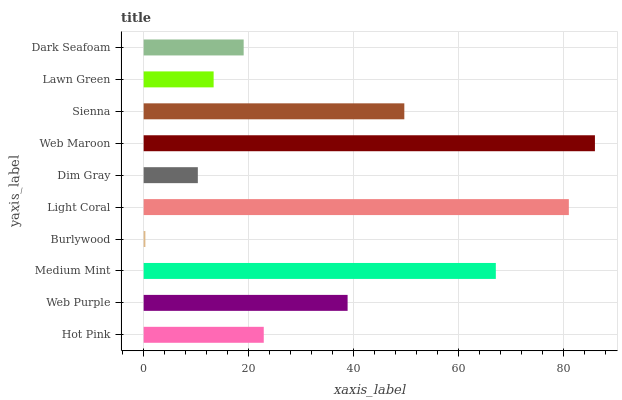Is Burlywood the minimum?
Answer yes or no. Yes. Is Web Maroon the maximum?
Answer yes or no. Yes. Is Web Purple the minimum?
Answer yes or no. No. Is Web Purple the maximum?
Answer yes or no. No. Is Web Purple greater than Hot Pink?
Answer yes or no. Yes. Is Hot Pink less than Web Purple?
Answer yes or no. Yes. Is Hot Pink greater than Web Purple?
Answer yes or no. No. Is Web Purple less than Hot Pink?
Answer yes or no. No. Is Web Purple the high median?
Answer yes or no. Yes. Is Hot Pink the low median?
Answer yes or no. Yes. Is Dark Seafoam the high median?
Answer yes or no. No. Is Lawn Green the low median?
Answer yes or no. No. 